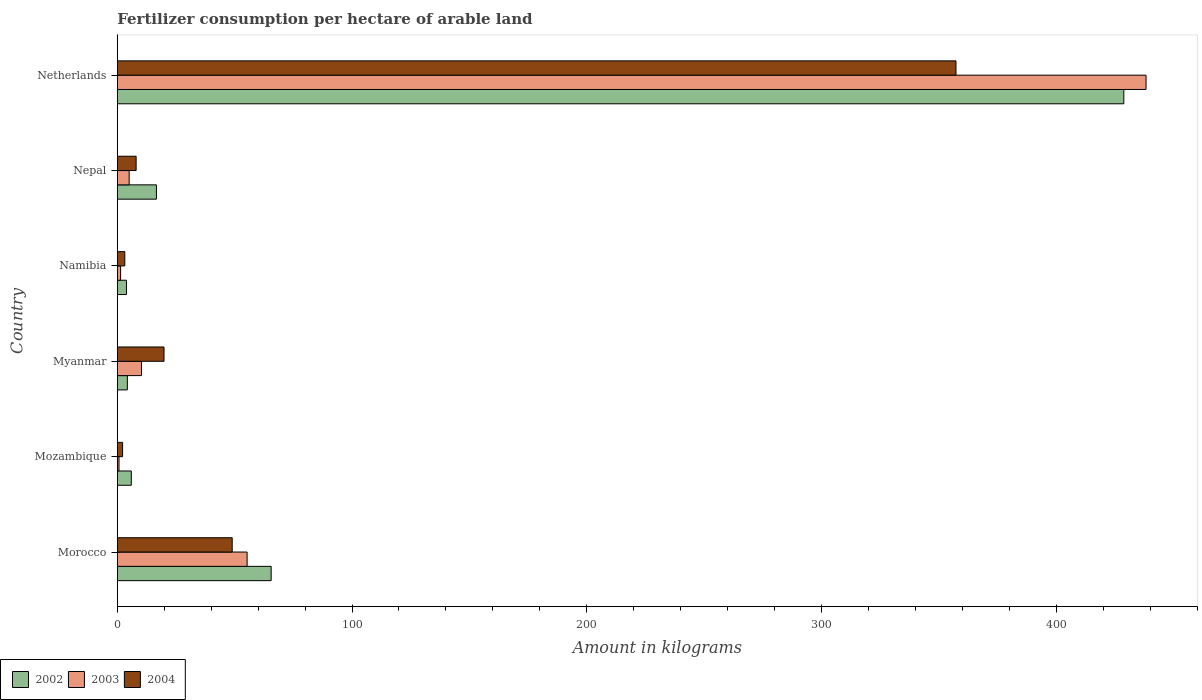Are the number of bars on each tick of the Y-axis equal?
Make the answer very short. Yes. How many bars are there on the 2nd tick from the top?
Your response must be concise. 3. What is the label of the 6th group of bars from the top?
Offer a very short reply. Morocco. What is the amount of fertilizer consumption in 2002 in Netherlands?
Your answer should be very brief. 428.82. Across all countries, what is the maximum amount of fertilizer consumption in 2004?
Offer a terse response. 357.31. Across all countries, what is the minimum amount of fertilizer consumption in 2004?
Your answer should be very brief. 2.26. In which country was the amount of fertilizer consumption in 2004 maximum?
Offer a terse response. Netherlands. In which country was the amount of fertilizer consumption in 2002 minimum?
Your answer should be compact. Namibia. What is the total amount of fertilizer consumption in 2003 in the graph?
Provide a succinct answer. 511.12. What is the difference between the amount of fertilizer consumption in 2004 in Morocco and that in Netherlands?
Keep it short and to the point. -308.36. What is the difference between the amount of fertilizer consumption in 2003 in Namibia and the amount of fertilizer consumption in 2002 in Myanmar?
Provide a succinct answer. -2.88. What is the average amount of fertilizer consumption in 2004 per country?
Provide a succinct answer. 73.28. What is the difference between the amount of fertilizer consumption in 2002 and amount of fertilizer consumption in 2004 in Morocco?
Give a very brief answer. 16.6. What is the ratio of the amount of fertilizer consumption in 2003 in Myanmar to that in Netherlands?
Your response must be concise. 0.02. Is the difference between the amount of fertilizer consumption in 2002 in Morocco and Myanmar greater than the difference between the amount of fertilizer consumption in 2004 in Morocco and Myanmar?
Give a very brief answer. Yes. What is the difference between the highest and the second highest amount of fertilizer consumption in 2003?
Your answer should be compact. 382.98. What is the difference between the highest and the lowest amount of fertilizer consumption in 2003?
Make the answer very short. 437.56. In how many countries, is the amount of fertilizer consumption in 2004 greater than the average amount of fertilizer consumption in 2004 taken over all countries?
Provide a succinct answer. 1. Is the sum of the amount of fertilizer consumption in 2002 in Mozambique and Nepal greater than the maximum amount of fertilizer consumption in 2004 across all countries?
Your answer should be very brief. No. What does the 3rd bar from the top in Myanmar represents?
Offer a terse response. 2002. What does the 2nd bar from the bottom in Mozambique represents?
Ensure brevity in your answer.  2003. How many bars are there?
Provide a succinct answer. 18. Are all the bars in the graph horizontal?
Keep it short and to the point. Yes. What is the difference between two consecutive major ticks on the X-axis?
Provide a succinct answer. 100. Does the graph contain grids?
Your answer should be very brief. No. How are the legend labels stacked?
Your answer should be very brief. Horizontal. What is the title of the graph?
Offer a very short reply. Fertilizer consumption per hectare of arable land. What is the label or title of the X-axis?
Provide a short and direct response. Amount in kilograms. What is the label or title of the Y-axis?
Your response must be concise. Country. What is the Amount in kilograms in 2002 in Morocco?
Provide a short and direct response. 65.55. What is the Amount in kilograms of 2003 in Morocco?
Keep it short and to the point. 55.31. What is the Amount in kilograms of 2004 in Morocco?
Your answer should be very brief. 48.96. What is the Amount in kilograms in 2002 in Mozambique?
Your answer should be compact. 5.98. What is the Amount in kilograms of 2003 in Mozambique?
Your answer should be compact. 0.74. What is the Amount in kilograms of 2004 in Mozambique?
Offer a very short reply. 2.26. What is the Amount in kilograms of 2002 in Myanmar?
Your answer should be very brief. 4.29. What is the Amount in kilograms of 2003 in Myanmar?
Your answer should be compact. 10.31. What is the Amount in kilograms of 2004 in Myanmar?
Ensure brevity in your answer.  19.91. What is the Amount in kilograms in 2002 in Namibia?
Offer a very short reply. 3.9. What is the Amount in kilograms in 2003 in Namibia?
Ensure brevity in your answer.  1.41. What is the Amount in kilograms in 2004 in Namibia?
Keep it short and to the point. 3.2. What is the Amount in kilograms in 2002 in Nepal?
Provide a succinct answer. 16.68. What is the Amount in kilograms of 2003 in Nepal?
Offer a terse response. 5.06. What is the Amount in kilograms of 2004 in Nepal?
Keep it short and to the point. 8.03. What is the Amount in kilograms in 2002 in Netherlands?
Make the answer very short. 428.82. What is the Amount in kilograms of 2003 in Netherlands?
Ensure brevity in your answer.  438.29. What is the Amount in kilograms in 2004 in Netherlands?
Give a very brief answer. 357.31. Across all countries, what is the maximum Amount in kilograms of 2002?
Keep it short and to the point. 428.82. Across all countries, what is the maximum Amount in kilograms of 2003?
Your response must be concise. 438.29. Across all countries, what is the maximum Amount in kilograms of 2004?
Provide a succinct answer. 357.31. Across all countries, what is the minimum Amount in kilograms in 2002?
Offer a terse response. 3.9. Across all countries, what is the minimum Amount in kilograms in 2003?
Your response must be concise. 0.74. Across all countries, what is the minimum Amount in kilograms of 2004?
Give a very brief answer. 2.26. What is the total Amount in kilograms in 2002 in the graph?
Make the answer very short. 525.23. What is the total Amount in kilograms in 2003 in the graph?
Keep it short and to the point. 511.12. What is the total Amount in kilograms in 2004 in the graph?
Offer a terse response. 439.67. What is the difference between the Amount in kilograms of 2002 in Morocco and that in Mozambique?
Keep it short and to the point. 59.58. What is the difference between the Amount in kilograms of 2003 in Morocco and that in Mozambique?
Give a very brief answer. 54.58. What is the difference between the Amount in kilograms of 2004 in Morocco and that in Mozambique?
Offer a terse response. 46.7. What is the difference between the Amount in kilograms of 2002 in Morocco and that in Myanmar?
Offer a terse response. 61.26. What is the difference between the Amount in kilograms of 2003 in Morocco and that in Myanmar?
Offer a very short reply. 45. What is the difference between the Amount in kilograms in 2004 in Morocco and that in Myanmar?
Your answer should be compact. 29.05. What is the difference between the Amount in kilograms of 2002 in Morocco and that in Namibia?
Your response must be concise. 61.65. What is the difference between the Amount in kilograms in 2003 in Morocco and that in Namibia?
Offer a very short reply. 53.9. What is the difference between the Amount in kilograms in 2004 in Morocco and that in Namibia?
Provide a short and direct response. 45.75. What is the difference between the Amount in kilograms of 2002 in Morocco and that in Nepal?
Your response must be concise. 48.87. What is the difference between the Amount in kilograms in 2003 in Morocco and that in Nepal?
Provide a succinct answer. 50.25. What is the difference between the Amount in kilograms of 2004 in Morocco and that in Nepal?
Offer a very short reply. 40.93. What is the difference between the Amount in kilograms in 2002 in Morocco and that in Netherlands?
Ensure brevity in your answer.  -363.27. What is the difference between the Amount in kilograms of 2003 in Morocco and that in Netherlands?
Provide a short and direct response. -382.98. What is the difference between the Amount in kilograms of 2004 in Morocco and that in Netherlands?
Provide a succinct answer. -308.36. What is the difference between the Amount in kilograms in 2002 in Mozambique and that in Myanmar?
Make the answer very short. 1.69. What is the difference between the Amount in kilograms of 2003 in Mozambique and that in Myanmar?
Keep it short and to the point. -9.57. What is the difference between the Amount in kilograms of 2004 in Mozambique and that in Myanmar?
Make the answer very short. -17.65. What is the difference between the Amount in kilograms in 2002 in Mozambique and that in Namibia?
Provide a short and direct response. 2.07. What is the difference between the Amount in kilograms of 2003 in Mozambique and that in Namibia?
Ensure brevity in your answer.  -0.67. What is the difference between the Amount in kilograms in 2004 in Mozambique and that in Namibia?
Keep it short and to the point. -0.95. What is the difference between the Amount in kilograms of 2002 in Mozambique and that in Nepal?
Offer a terse response. -10.7. What is the difference between the Amount in kilograms of 2003 in Mozambique and that in Nepal?
Make the answer very short. -4.32. What is the difference between the Amount in kilograms in 2004 in Mozambique and that in Nepal?
Give a very brief answer. -5.77. What is the difference between the Amount in kilograms of 2002 in Mozambique and that in Netherlands?
Ensure brevity in your answer.  -422.85. What is the difference between the Amount in kilograms in 2003 in Mozambique and that in Netherlands?
Offer a very short reply. -437.56. What is the difference between the Amount in kilograms in 2004 in Mozambique and that in Netherlands?
Make the answer very short. -355.05. What is the difference between the Amount in kilograms in 2002 in Myanmar and that in Namibia?
Keep it short and to the point. 0.39. What is the difference between the Amount in kilograms of 2003 in Myanmar and that in Namibia?
Your answer should be compact. 8.9. What is the difference between the Amount in kilograms of 2004 in Myanmar and that in Namibia?
Keep it short and to the point. 16.71. What is the difference between the Amount in kilograms of 2002 in Myanmar and that in Nepal?
Provide a succinct answer. -12.39. What is the difference between the Amount in kilograms in 2003 in Myanmar and that in Nepal?
Offer a terse response. 5.25. What is the difference between the Amount in kilograms in 2004 in Myanmar and that in Nepal?
Provide a succinct answer. 11.89. What is the difference between the Amount in kilograms in 2002 in Myanmar and that in Netherlands?
Provide a succinct answer. -424.53. What is the difference between the Amount in kilograms in 2003 in Myanmar and that in Netherlands?
Make the answer very short. -427.98. What is the difference between the Amount in kilograms in 2004 in Myanmar and that in Netherlands?
Your answer should be very brief. -337.4. What is the difference between the Amount in kilograms of 2002 in Namibia and that in Nepal?
Your answer should be compact. -12.78. What is the difference between the Amount in kilograms of 2003 in Namibia and that in Nepal?
Keep it short and to the point. -3.65. What is the difference between the Amount in kilograms of 2004 in Namibia and that in Nepal?
Offer a terse response. -4.82. What is the difference between the Amount in kilograms in 2002 in Namibia and that in Netherlands?
Your answer should be very brief. -424.92. What is the difference between the Amount in kilograms of 2003 in Namibia and that in Netherlands?
Make the answer very short. -436.88. What is the difference between the Amount in kilograms of 2004 in Namibia and that in Netherlands?
Offer a very short reply. -354.11. What is the difference between the Amount in kilograms in 2002 in Nepal and that in Netherlands?
Ensure brevity in your answer.  -412.14. What is the difference between the Amount in kilograms in 2003 in Nepal and that in Netherlands?
Offer a terse response. -433.23. What is the difference between the Amount in kilograms of 2004 in Nepal and that in Netherlands?
Your answer should be compact. -349.29. What is the difference between the Amount in kilograms in 2002 in Morocco and the Amount in kilograms in 2003 in Mozambique?
Ensure brevity in your answer.  64.82. What is the difference between the Amount in kilograms of 2002 in Morocco and the Amount in kilograms of 2004 in Mozambique?
Offer a terse response. 63.29. What is the difference between the Amount in kilograms of 2003 in Morocco and the Amount in kilograms of 2004 in Mozambique?
Provide a succinct answer. 53.05. What is the difference between the Amount in kilograms of 2002 in Morocco and the Amount in kilograms of 2003 in Myanmar?
Provide a short and direct response. 55.25. What is the difference between the Amount in kilograms of 2002 in Morocco and the Amount in kilograms of 2004 in Myanmar?
Give a very brief answer. 45.64. What is the difference between the Amount in kilograms of 2003 in Morocco and the Amount in kilograms of 2004 in Myanmar?
Give a very brief answer. 35.4. What is the difference between the Amount in kilograms of 2002 in Morocco and the Amount in kilograms of 2003 in Namibia?
Your answer should be very brief. 64.14. What is the difference between the Amount in kilograms of 2002 in Morocco and the Amount in kilograms of 2004 in Namibia?
Keep it short and to the point. 62.35. What is the difference between the Amount in kilograms of 2003 in Morocco and the Amount in kilograms of 2004 in Namibia?
Offer a very short reply. 52.11. What is the difference between the Amount in kilograms in 2002 in Morocco and the Amount in kilograms in 2003 in Nepal?
Offer a very short reply. 60.5. What is the difference between the Amount in kilograms of 2002 in Morocco and the Amount in kilograms of 2004 in Nepal?
Give a very brief answer. 57.53. What is the difference between the Amount in kilograms in 2003 in Morocco and the Amount in kilograms in 2004 in Nepal?
Provide a short and direct response. 47.29. What is the difference between the Amount in kilograms in 2002 in Morocco and the Amount in kilograms in 2003 in Netherlands?
Offer a terse response. -372.74. What is the difference between the Amount in kilograms in 2002 in Morocco and the Amount in kilograms in 2004 in Netherlands?
Provide a succinct answer. -291.76. What is the difference between the Amount in kilograms in 2003 in Morocco and the Amount in kilograms in 2004 in Netherlands?
Keep it short and to the point. -302. What is the difference between the Amount in kilograms in 2002 in Mozambique and the Amount in kilograms in 2003 in Myanmar?
Ensure brevity in your answer.  -4.33. What is the difference between the Amount in kilograms in 2002 in Mozambique and the Amount in kilograms in 2004 in Myanmar?
Ensure brevity in your answer.  -13.93. What is the difference between the Amount in kilograms in 2003 in Mozambique and the Amount in kilograms in 2004 in Myanmar?
Your response must be concise. -19.18. What is the difference between the Amount in kilograms of 2002 in Mozambique and the Amount in kilograms of 2003 in Namibia?
Give a very brief answer. 4.57. What is the difference between the Amount in kilograms of 2002 in Mozambique and the Amount in kilograms of 2004 in Namibia?
Offer a terse response. 2.77. What is the difference between the Amount in kilograms in 2003 in Mozambique and the Amount in kilograms in 2004 in Namibia?
Provide a short and direct response. -2.47. What is the difference between the Amount in kilograms of 2002 in Mozambique and the Amount in kilograms of 2003 in Nepal?
Your answer should be very brief. 0.92. What is the difference between the Amount in kilograms of 2002 in Mozambique and the Amount in kilograms of 2004 in Nepal?
Your answer should be very brief. -2.05. What is the difference between the Amount in kilograms in 2003 in Mozambique and the Amount in kilograms in 2004 in Nepal?
Give a very brief answer. -7.29. What is the difference between the Amount in kilograms of 2002 in Mozambique and the Amount in kilograms of 2003 in Netherlands?
Provide a short and direct response. -432.31. What is the difference between the Amount in kilograms in 2002 in Mozambique and the Amount in kilograms in 2004 in Netherlands?
Give a very brief answer. -351.34. What is the difference between the Amount in kilograms in 2003 in Mozambique and the Amount in kilograms in 2004 in Netherlands?
Ensure brevity in your answer.  -356.58. What is the difference between the Amount in kilograms of 2002 in Myanmar and the Amount in kilograms of 2003 in Namibia?
Your response must be concise. 2.88. What is the difference between the Amount in kilograms in 2002 in Myanmar and the Amount in kilograms in 2004 in Namibia?
Offer a very short reply. 1.09. What is the difference between the Amount in kilograms in 2003 in Myanmar and the Amount in kilograms in 2004 in Namibia?
Offer a very short reply. 7.1. What is the difference between the Amount in kilograms in 2002 in Myanmar and the Amount in kilograms in 2003 in Nepal?
Your answer should be compact. -0.77. What is the difference between the Amount in kilograms in 2002 in Myanmar and the Amount in kilograms in 2004 in Nepal?
Offer a terse response. -3.74. What is the difference between the Amount in kilograms in 2003 in Myanmar and the Amount in kilograms in 2004 in Nepal?
Provide a succinct answer. 2.28. What is the difference between the Amount in kilograms in 2002 in Myanmar and the Amount in kilograms in 2003 in Netherlands?
Offer a very short reply. -434. What is the difference between the Amount in kilograms of 2002 in Myanmar and the Amount in kilograms of 2004 in Netherlands?
Your answer should be very brief. -353.02. What is the difference between the Amount in kilograms of 2003 in Myanmar and the Amount in kilograms of 2004 in Netherlands?
Provide a succinct answer. -347. What is the difference between the Amount in kilograms in 2002 in Namibia and the Amount in kilograms in 2003 in Nepal?
Provide a succinct answer. -1.16. What is the difference between the Amount in kilograms of 2002 in Namibia and the Amount in kilograms of 2004 in Nepal?
Offer a very short reply. -4.12. What is the difference between the Amount in kilograms of 2003 in Namibia and the Amount in kilograms of 2004 in Nepal?
Your answer should be compact. -6.61. What is the difference between the Amount in kilograms in 2002 in Namibia and the Amount in kilograms in 2003 in Netherlands?
Give a very brief answer. -434.39. What is the difference between the Amount in kilograms of 2002 in Namibia and the Amount in kilograms of 2004 in Netherlands?
Your answer should be very brief. -353.41. What is the difference between the Amount in kilograms in 2003 in Namibia and the Amount in kilograms in 2004 in Netherlands?
Your answer should be very brief. -355.9. What is the difference between the Amount in kilograms in 2002 in Nepal and the Amount in kilograms in 2003 in Netherlands?
Offer a very short reply. -421.61. What is the difference between the Amount in kilograms of 2002 in Nepal and the Amount in kilograms of 2004 in Netherlands?
Ensure brevity in your answer.  -340.63. What is the difference between the Amount in kilograms of 2003 in Nepal and the Amount in kilograms of 2004 in Netherlands?
Offer a terse response. -352.25. What is the average Amount in kilograms in 2002 per country?
Your response must be concise. 87.54. What is the average Amount in kilograms in 2003 per country?
Make the answer very short. 85.19. What is the average Amount in kilograms in 2004 per country?
Make the answer very short. 73.28. What is the difference between the Amount in kilograms of 2002 and Amount in kilograms of 2003 in Morocco?
Ensure brevity in your answer.  10.24. What is the difference between the Amount in kilograms of 2002 and Amount in kilograms of 2004 in Morocco?
Your response must be concise. 16.6. What is the difference between the Amount in kilograms of 2003 and Amount in kilograms of 2004 in Morocco?
Your response must be concise. 6.35. What is the difference between the Amount in kilograms of 2002 and Amount in kilograms of 2003 in Mozambique?
Your answer should be compact. 5.24. What is the difference between the Amount in kilograms in 2002 and Amount in kilograms in 2004 in Mozambique?
Provide a succinct answer. 3.72. What is the difference between the Amount in kilograms in 2003 and Amount in kilograms in 2004 in Mozambique?
Offer a very short reply. -1.52. What is the difference between the Amount in kilograms of 2002 and Amount in kilograms of 2003 in Myanmar?
Provide a succinct answer. -6.02. What is the difference between the Amount in kilograms of 2002 and Amount in kilograms of 2004 in Myanmar?
Provide a short and direct response. -15.62. What is the difference between the Amount in kilograms of 2003 and Amount in kilograms of 2004 in Myanmar?
Keep it short and to the point. -9.6. What is the difference between the Amount in kilograms in 2002 and Amount in kilograms in 2003 in Namibia?
Your answer should be compact. 2.49. What is the difference between the Amount in kilograms in 2002 and Amount in kilograms in 2004 in Namibia?
Your answer should be very brief. 0.7. What is the difference between the Amount in kilograms of 2003 and Amount in kilograms of 2004 in Namibia?
Provide a succinct answer. -1.79. What is the difference between the Amount in kilograms of 2002 and Amount in kilograms of 2003 in Nepal?
Provide a short and direct response. 11.62. What is the difference between the Amount in kilograms of 2002 and Amount in kilograms of 2004 in Nepal?
Offer a very short reply. 8.66. What is the difference between the Amount in kilograms of 2003 and Amount in kilograms of 2004 in Nepal?
Offer a terse response. -2.97. What is the difference between the Amount in kilograms of 2002 and Amount in kilograms of 2003 in Netherlands?
Ensure brevity in your answer.  -9.47. What is the difference between the Amount in kilograms in 2002 and Amount in kilograms in 2004 in Netherlands?
Give a very brief answer. 71.51. What is the difference between the Amount in kilograms of 2003 and Amount in kilograms of 2004 in Netherlands?
Make the answer very short. 80.98. What is the ratio of the Amount in kilograms in 2002 in Morocco to that in Mozambique?
Make the answer very short. 10.97. What is the ratio of the Amount in kilograms of 2003 in Morocco to that in Mozambique?
Provide a succinct answer. 75.13. What is the ratio of the Amount in kilograms of 2004 in Morocco to that in Mozambique?
Offer a terse response. 21.66. What is the ratio of the Amount in kilograms of 2002 in Morocco to that in Myanmar?
Provide a short and direct response. 15.28. What is the ratio of the Amount in kilograms in 2003 in Morocco to that in Myanmar?
Your answer should be compact. 5.37. What is the ratio of the Amount in kilograms of 2004 in Morocco to that in Myanmar?
Your response must be concise. 2.46. What is the ratio of the Amount in kilograms of 2002 in Morocco to that in Namibia?
Your answer should be compact. 16.8. What is the ratio of the Amount in kilograms of 2003 in Morocco to that in Namibia?
Your answer should be very brief. 39.2. What is the ratio of the Amount in kilograms in 2004 in Morocco to that in Namibia?
Give a very brief answer. 15.28. What is the ratio of the Amount in kilograms in 2002 in Morocco to that in Nepal?
Provide a short and direct response. 3.93. What is the ratio of the Amount in kilograms of 2003 in Morocco to that in Nepal?
Make the answer very short. 10.93. What is the ratio of the Amount in kilograms in 2004 in Morocco to that in Nepal?
Your answer should be compact. 6.1. What is the ratio of the Amount in kilograms of 2002 in Morocco to that in Netherlands?
Make the answer very short. 0.15. What is the ratio of the Amount in kilograms of 2003 in Morocco to that in Netherlands?
Offer a terse response. 0.13. What is the ratio of the Amount in kilograms in 2004 in Morocco to that in Netherlands?
Your response must be concise. 0.14. What is the ratio of the Amount in kilograms of 2002 in Mozambique to that in Myanmar?
Your answer should be compact. 1.39. What is the ratio of the Amount in kilograms of 2003 in Mozambique to that in Myanmar?
Keep it short and to the point. 0.07. What is the ratio of the Amount in kilograms in 2004 in Mozambique to that in Myanmar?
Offer a very short reply. 0.11. What is the ratio of the Amount in kilograms of 2002 in Mozambique to that in Namibia?
Make the answer very short. 1.53. What is the ratio of the Amount in kilograms of 2003 in Mozambique to that in Namibia?
Your answer should be compact. 0.52. What is the ratio of the Amount in kilograms in 2004 in Mozambique to that in Namibia?
Offer a very short reply. 0.71. What is the ratio of the Amount in kilograms of 2002 in Mozambique to that in Nepal?
Your response must be concise. 0.36. What is the ratio of the Amount in kilograms in 2003 in Mozambique to that in Nepal?
Make the answer very short. 0.15. What is the ratio of the Amount in kilograms in 2004 in Mozambique to that in Nepal?
Ensure brevity in your answer.  0.28. What is the ratio of the Amount in kilograms in 2002 in Mozambique to that in Netherlands?
Provide a succinct answer. 0.01. What is the ratio of the Amount in kilograms of 2003 in Mozambique to that in Netherlands?
Your answer should be compact. 0. What is the ratio of the Amount in kilograms of 2004 in Mozambique to that in Netherlands?
Offer a terse response. 0.01. What is the ratio of the Amount in kilograms of 2002 in Myanmar to that in Namibia?
Your answer should be compact. 1.1. What is the ratio of the Amount in kilograms in 2003 in Myanmar to that in Namibia?
Your response must be concise. 7.31. What is the ratio of the Amount in kilograms in 2004 in Myanmar to that in Namibia?
Offer a very short reply. 6.21. What is the ratio of the Amount in kilograms of 2002 in Myanmar to that in Nepal?
Provide a short and direct response. 0.26. What is the ratio of the Amount in kilograms of 2003 in Myanmar to that in Nepal?
Your response must be concise. 2.04. What is the ratio of the Amount in kilograms in 2004 in Myanmar to that in Nepal?
Your response must be concise. 2.48. What is the ratio of the Amount in kilograms of 2002 in Myanmar to that in Netherlands?
Ensure brevity in your answer.  0.01. What is the ratio of the Amount in kilograms of 2003 in Myanmar to that in Netherlands?
Make the answer very short. 0.02. What is the ratio of the Amount in kilograms of 2004 in Myanmar to that in Netherlands?
Your answer should be compact. 0.06. What is the ratio of the Amount in kilograms in 2002 in Namibia to that in Nepal?
Make the answer very short. 0.23. What is the ratio of the Amount in kilograms in 2003 in Namibia to that in Nepal?
Your answer should be very brief. 0.28. What is the ratio of the Amount in kilograms of 2004 in Namibia to that in Nepal?
Give a very brief answer. 0.4. What is the ratio of the Amount in kilograms of 2002 in Namibia to that in Netherlands?
Provide a short and direct response. 0.01. What is the ratio of the Amount in kilograms in 2003 in Namibia to that in Netherlands?
Provide a succinct answer. 0. What is the ratio of the Amount in kilograms in 2004 in Namibia to that in Netherlands?
Give a very brief answer. 0.01. What is the ratio of the Amount in kilograms of 2002 in Nepal to that in Netherlands?
Your answer should be compact. 0.04. What is the ratio of the Amount in kilograms of 2003 in Nepal to that in Netherlands?
Give a very brief answer. 0.01. What is the ratio of the Amount in kilograms in 2004 in Nepal to that in Netherlands?
Provide a short and direct response. 0.02. What is the difference between the highest and the second highest Amount in kilograms of 2002?
Your response must be concise. 363.27. What is the difference between the highest and the second highest Amount in kilograms in 2003?
Your answer should be very brief. 382.98. What is the difference between the highest and the second highest Amount in kilograms of 2004?
Offer a terse response. 308.36. What is the difference between the highest and the lowest Amount in kilograms in 2002?
Make the answer very short. 424.92. What is the difference between the highest and the lowest Amount in kilograms of 2003?
Make the answer very short. 437.56. What is the difference between the highest and the lowest Amount in kilograms in 2004?
Offer a very short reply. 355.05. 